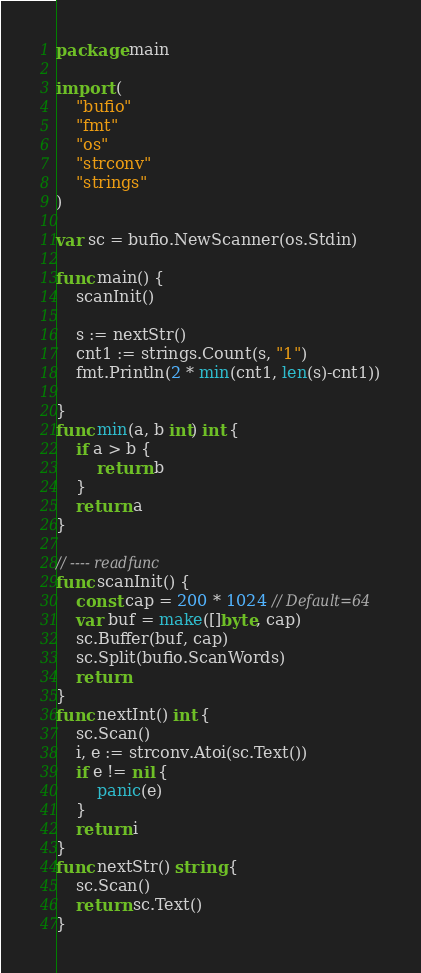<code> <loc_0><loc_0><loc_500><loc_500><_Go_>package main

import (
	"bufio"
	"fmt"
	"os"
	"strconv"
	"strings"
)

var sc = bufio.NewScanner(os.Stdin)

func main() {
	scanInit()

	s := nextStr()
	cnt1 := strings.Count(s, "1")
	fmt.Println(2 * min(cnt1, len(s)-cnt1))

}
func min(a, b int) int {
	if a > b {
		return b
	}
	return a
}

// ---- readfunc
func scanInit() {
	const cap = 200 * 1024 // Default=64
	var buf = make([]byte, cap)
	sc.Buffer(buf, cap)
	sc.Split(bufio.ScanWords)
	return
}
func nextInt() int {
	sc.Scan()
	i, e := strconv.Atoi(sc.Text())
	if e != nil {
		panic(e)
	}
	return i
}
func nextStr() string {
	sc.Scan()
	return sc.Text()
}
</code> 